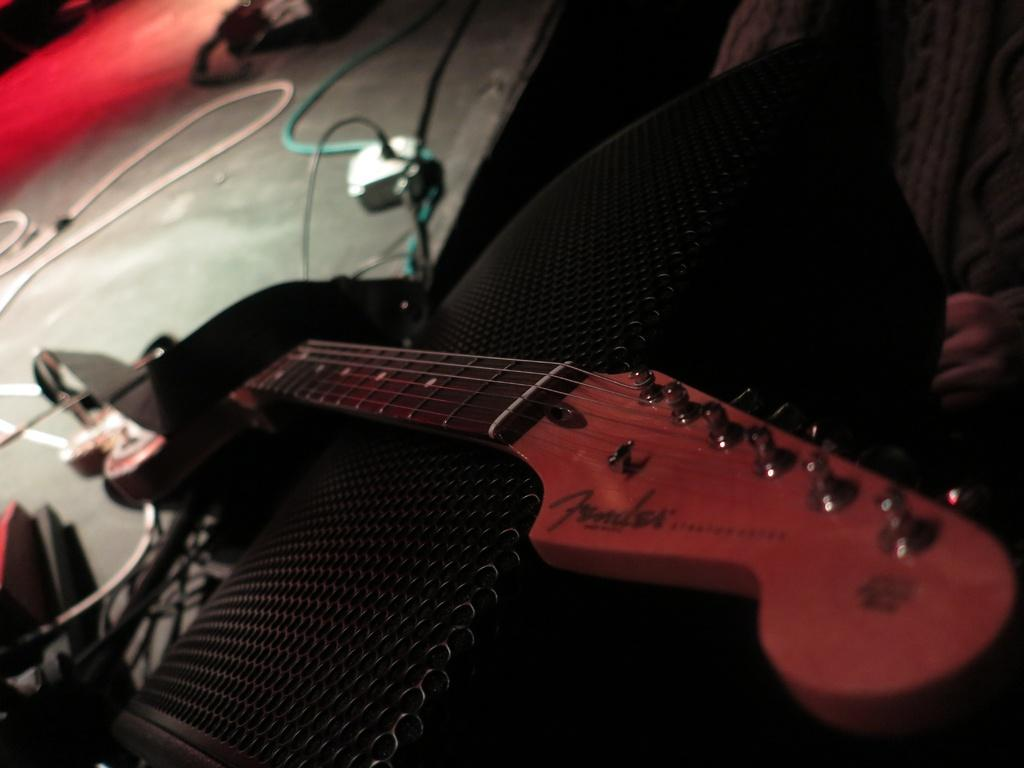What musical instrument is present in the image? There is a guitar with strings in the image. What can be seen in the background of the image? There is a speaker in the background of the image. What connects the guitar to the speaker in the image? Wires are visible in the image, which likely connect the guitar to the speaker. What type of loaf is being used as a stand for the guitar in the image? There is no loaf present in the image, and the guitar is not being supported by any stand. 